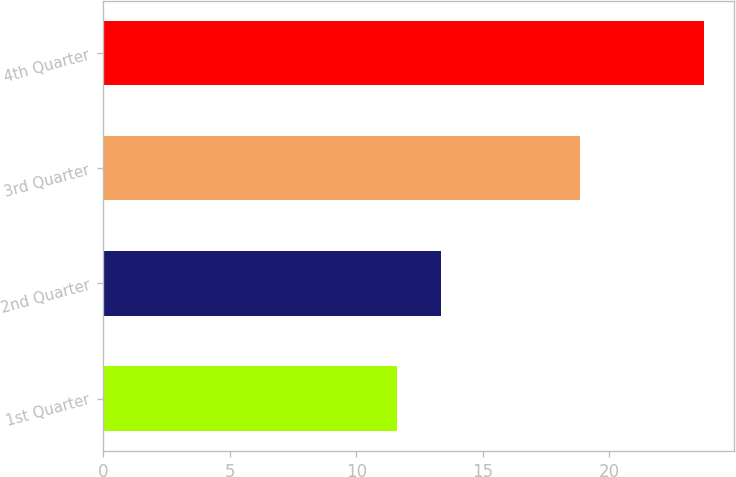<chart> <loc_0><loc_0><loc_500><loc_500><bar_chart><fcel>1st Quarter<fcel>2nd Quarter<fcel>3rd Quarter<fcel>4th Quarter<nl><fcel>11.62<fcel>13.36<fcel>18.85<fcel>23.75<nl></chart> 